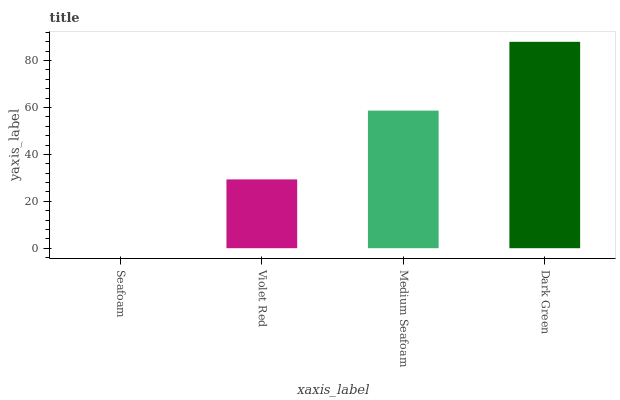Is Seafoam the minimum?
Answer yes or no. Yes. Is Dark Green the maximum?
Answer yes or no. Yes. Is Violet Red the minimum?
Answer yes or no. No. Is Violet Red the maximum?
Answer yes or no. No. Is Violet Red greater than Seafoam?
Answer yes or no. Yes. Is Seafoam less than Violet Red?
Answer yes or no. Yes. Is Seafoam greater than Violet Red?
Answer yes or no. No. Is Violet Red less than Seafoam?
Answer yes or no. No. Is Medium Seafoam the high median?
Answer yes or no. Yes. Is Violet Red the low median?
Answer yes or no. Yes. Is Violet Red the high median?
Answer yes or no. No. Is Dark Green the low median?
Answer yes or no. No. 